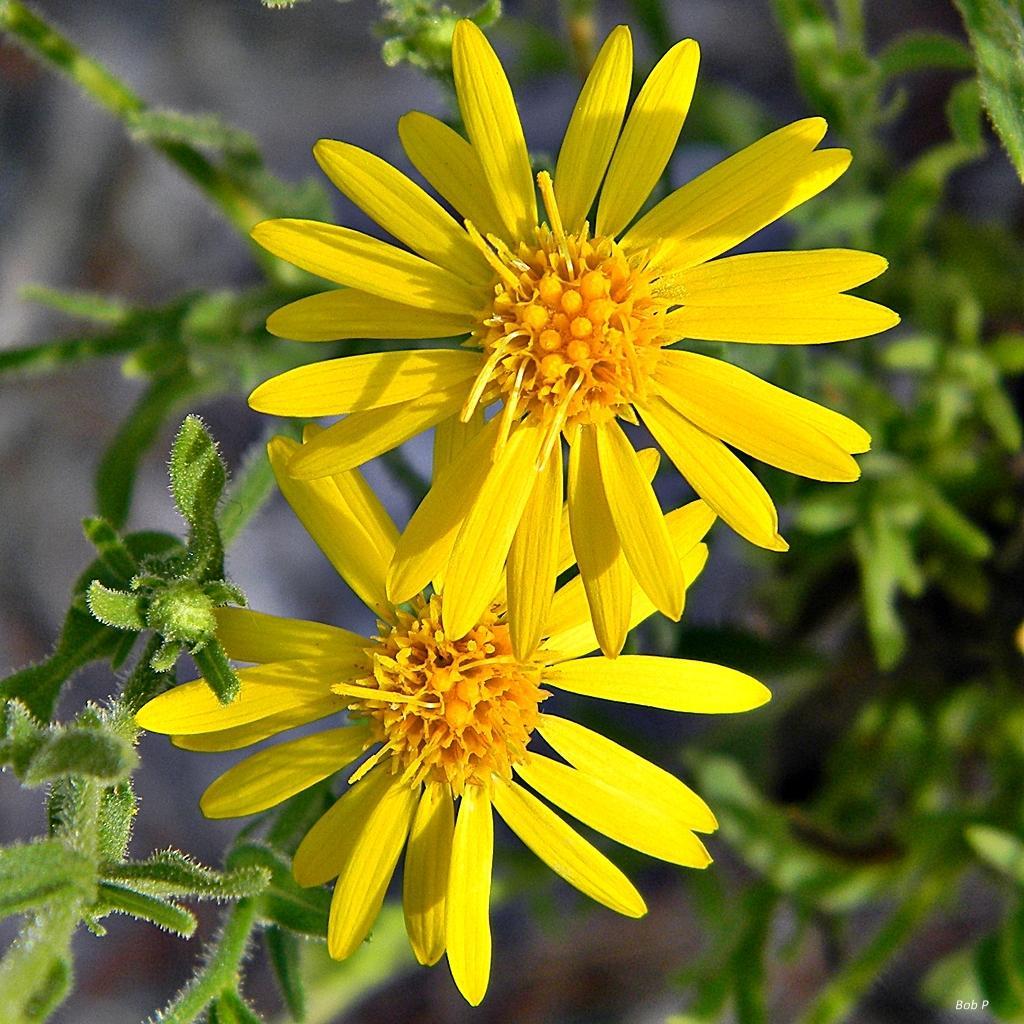Describe this image in one or two sentences. There are plants truncated towards the right of the image, there are plants truncated towards the left of the image, there are flowers, the background of the image is blurred. 